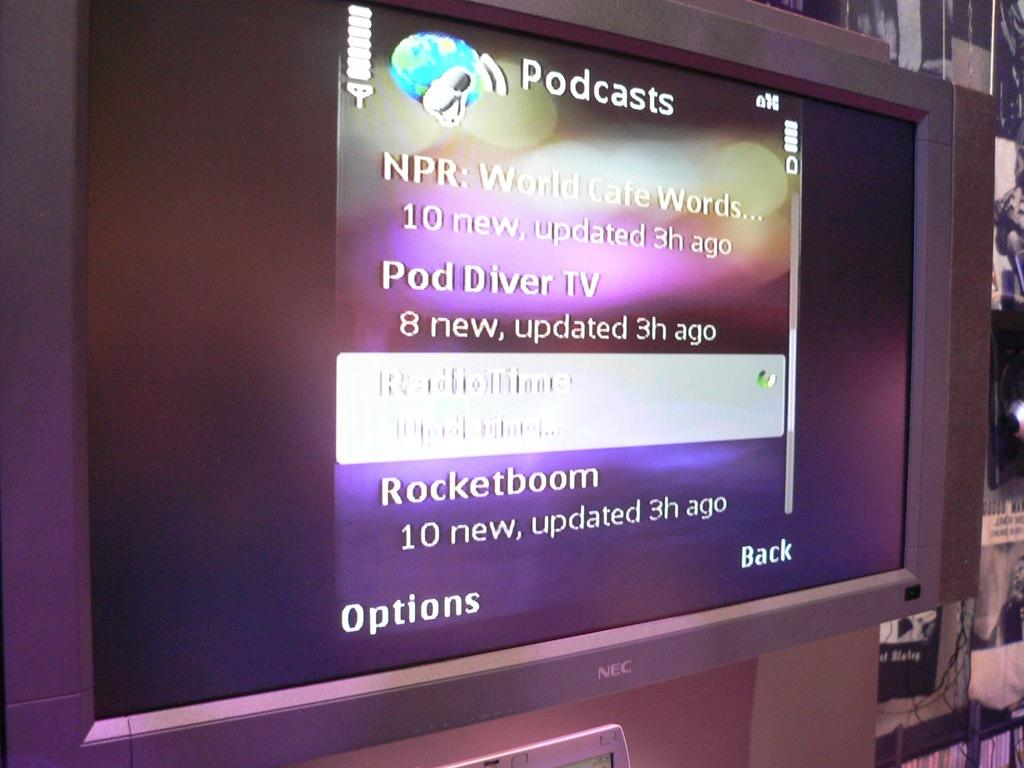<image>
Create a compact narrative representing the image presented. A very big NEC screen that says Podcasts at the top. 